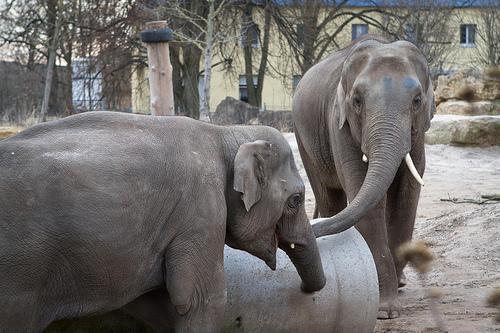How many tusks does the elephant on the right have?
Give a very brief answer. 1. How many elephants are in the picture?
Give a very brief answer. 2. How many ears do the elephants have?
Give a very brief answer. 2. 